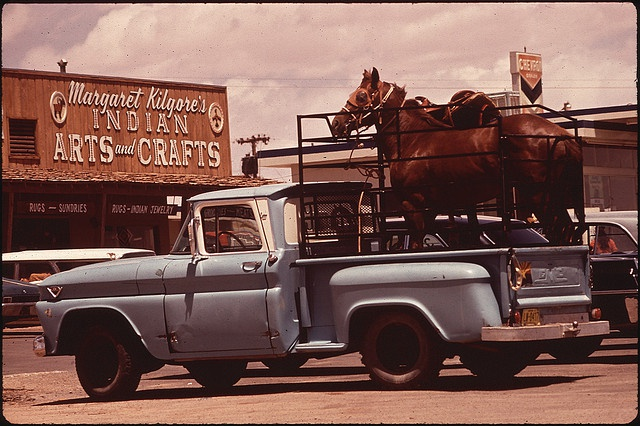Describe the objects in this image and their specific colors. I can see truck in black, maroon, gray, and darkgray tones, horse in black, maroon, and brown tones, car in black, maroon, brown, and tan tones, car in black, maroon, and brown tones, and people in black, maroon, and brown tones in this image. 